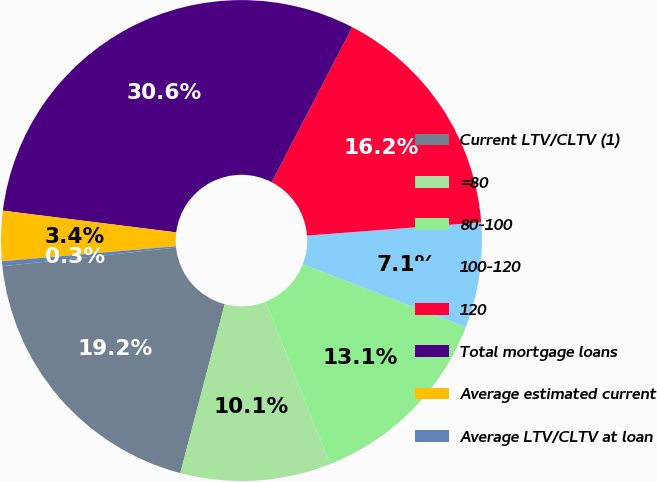<chart> <loc_0><loc_0><loc_500><loc_500><pie_chart><fcel>Current LTV/CLTV (1)<fcel>=80<fcel>80-100<fcel>100-120<fcel>120<fcel>Total mortgage loans<fcel>Average estimated current<fcel>Average LTV/CLTV at loan<nl><fcel>19.2%<fcel>10.1%<fcel>13.13%<fcel>7.07%<fcel>16.17%<fcel>30.64%<fcel>3.36%<fcel>0.33%<nl></chart> 